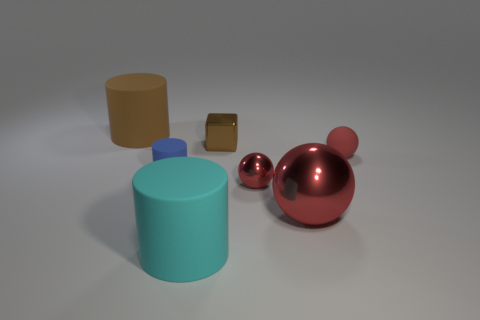Is there a small rubber ball that has the same color as the small metallic block? After examining the image, it is clear that there is no small rubber ball present that shares the same color as the small metallic block. The metallic block appears to be a gold or bronze color, while there are no rubber balls with a similar hue in the scene. 